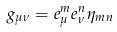Convert formula to latex. <formula><loc_0><loc_0><loc_500><loc_500>g _ { \mu \nu } = e _ { \mu } ^ { m } e _ { \nu } ^ { n } \eta _ { m n }</formula> 